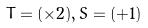Convert formula to latex. <formula><loc_0><loc_0><loc_500><loc_500>T = ( \times 2 ) , S = ( + 1 )</formula> 